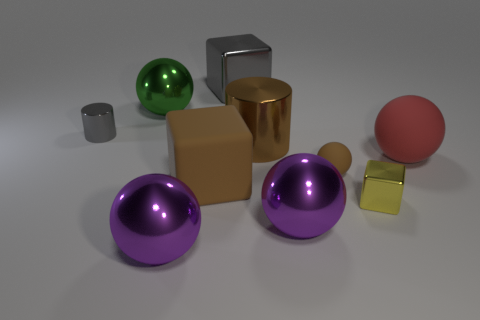Subtract 1 balls. How many balls are left? 4 Subtract all green balls. How many balls are left? 4 Subtract all red balls. How many balls are left? 4 Subtract all yellow spheres. Subtract all brown cubes. How many spheres are left? 5 Subtract all cubes. How many objects are left? 7 Subtract all rubber cylinders. Subtract all small metallic cylinders. How many objects are left? 9 Add 2 large rubber cubes. How many large rubber cubes are left? 3 Add 8 tiny yellow shiny objects. How many tiny yellow shiny objects exist? 9 Subtract 0 blue cylinders. How many objects are left? 10 